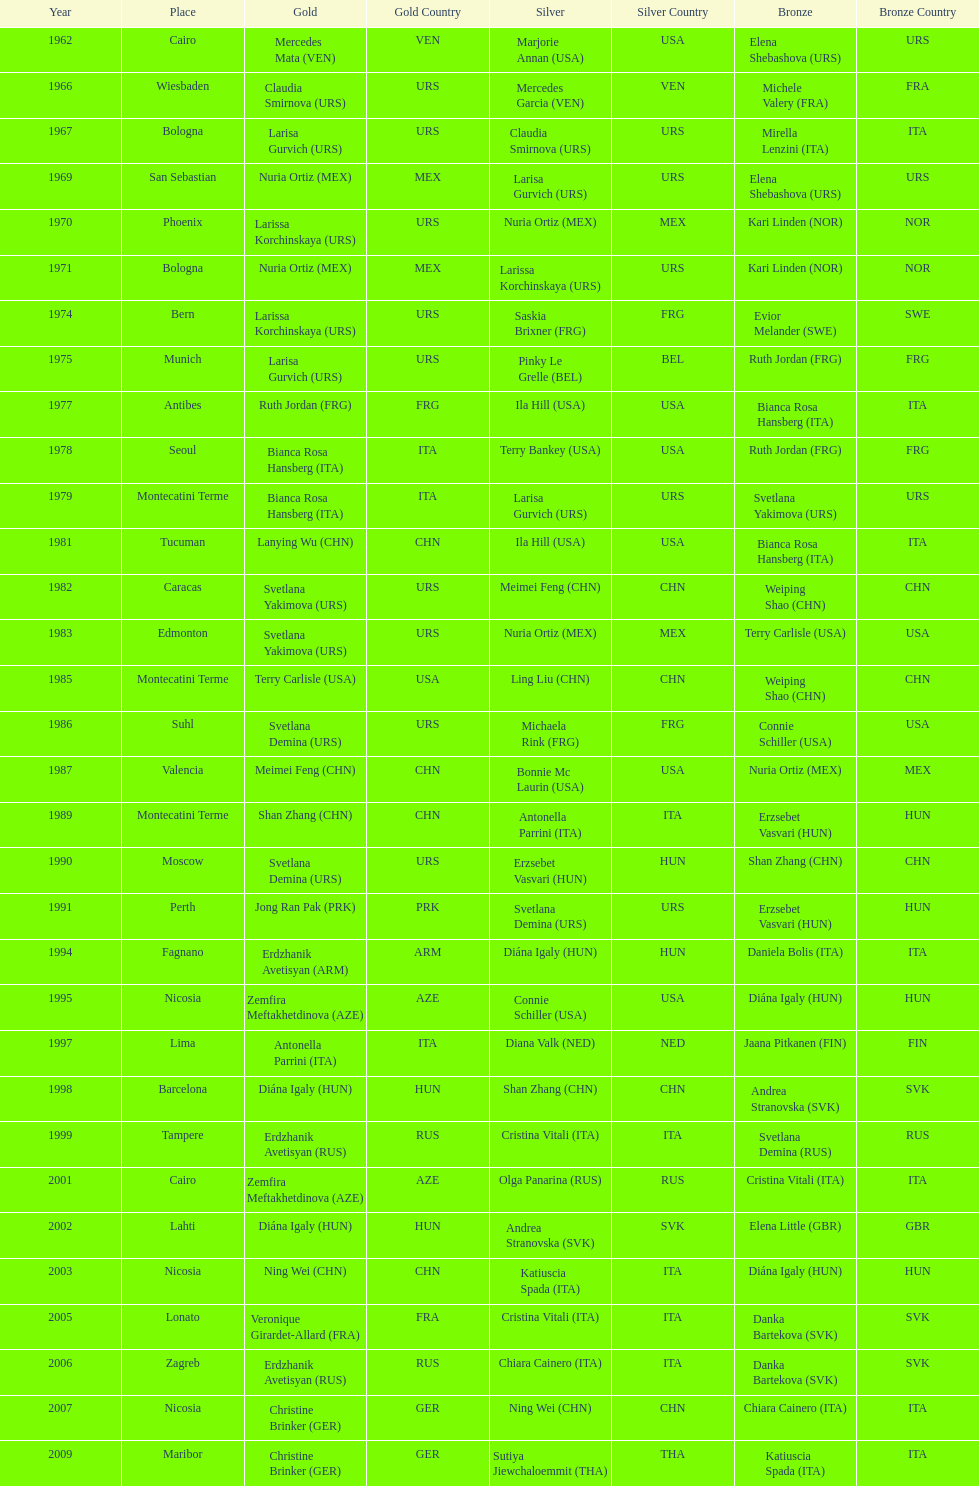How many gold did u.s.a win 1. 